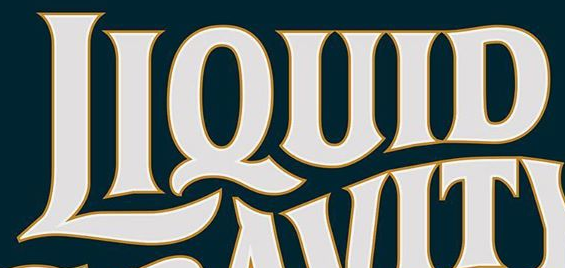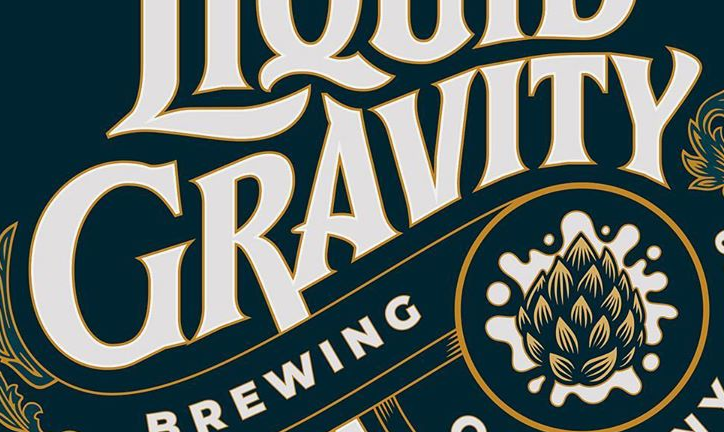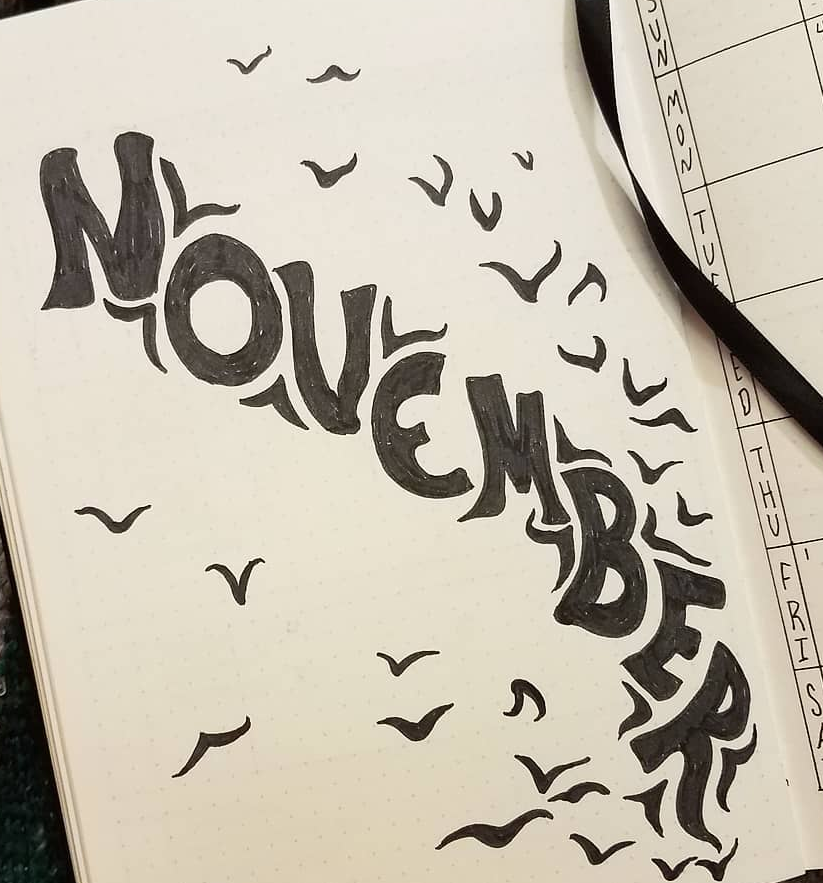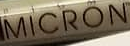What words can you see in these images in sequence, separated by a semicolon? LIQUID; GRAVITY; NOVEMBER; MICRON 